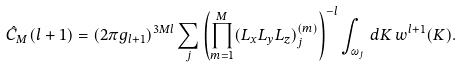<formula> <loc_0><loc_0><loc_500><loc_500>\hat { C } _ { M } ( l + 1 ) = ( 2 \pi g _ { l + 1 } ) ^ { 3 M l } \sum _ { j } \left ( \prod _ { m = 1 } ^ { M } ( L _ { x } L _ { y } L _ { z } ) _ { j } ^ { ( m ) } \right ) ^ { - l } \int _ { \omega _ { j } } \, d K \, w ^ { l + 1 } ( K ) .</formula> 